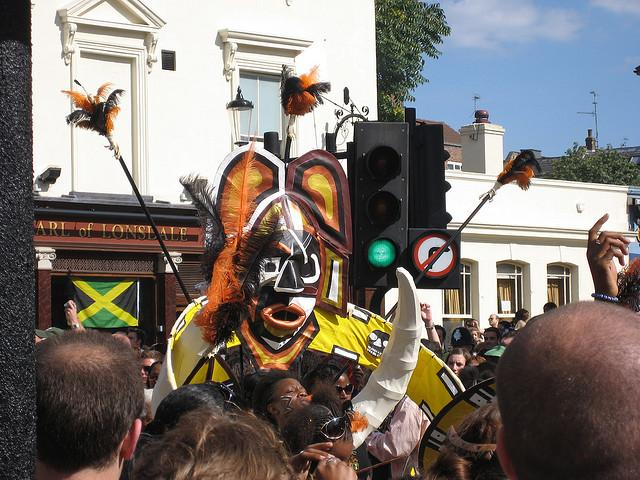What does the color of traffic light in the above picture imply to road users? go 